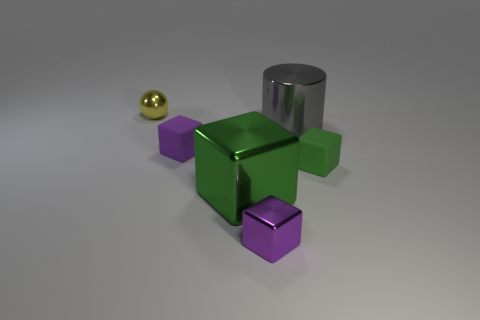What is the material of the green object right of the shiny object that is to the right of the small metallic object that is to the right of the yellow sphere?
Your answer should be compact. Rubber. Does the big green thing have the same shape as the green rubber object?
Ensure brevity in your answer.  Yes. How many small things are in front of the small yellow object and behind the small metal cube?
Offer a terse response. 2. There is a tiny cube that is in front of the green object right of the big green shiny block; what color is it?
Give a very brief answer. Purple. Is the number of tiny metallic objects that are behind the purple metallic thing the same as the number of gray things?
Provide a short and direct response. Yes. There is a purple object that is in front of the small green thing that is to the right of the cylinder; what number of gray metallic cylinders are on the right side of it?
Give a very brief answer. 1. There is a large thing in front of the big gray shiny object; what is its color?
Provide a succinct answer. Green. There is a thing that is both on the left side of the big gray object and behind the purple matte object; what material is it made of?
Provide a succinct answer. Metal. How many small matte things are on the left side of the rubber cube on the right side of the cylinder?
Offer a very short reply. 1. The gray thing is what shape?
Your answer should be very brief. Cylinder. 